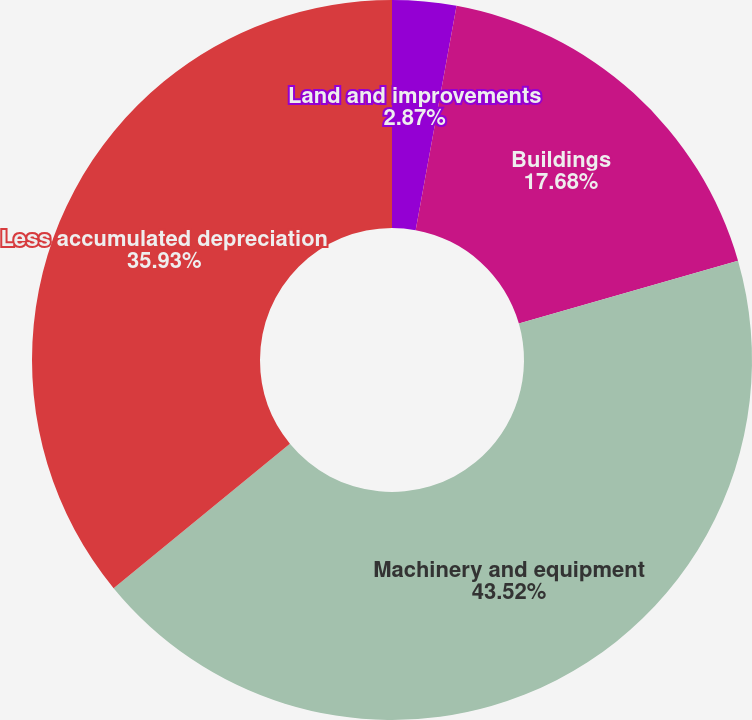<chart> <loc_0><loc_0><loc_500><loc_500><pie_chart><fcel>Land and improvements<fcel>Buildings<fcel>Machinery and equipment<fcel>Less accumulated depreciation<nl><fcel>2.87%<fcel>17.68%<fcel>43.52%<fcel>35.93%<nl></chart> 